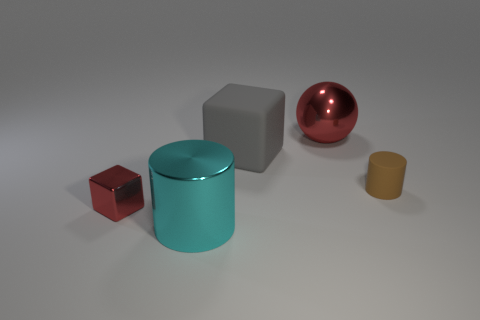What is the size of the red metallic sphere?
Your response must be concise. Large. Is the size of the cylinder in front of the rubber cylinder the same as the metallic thing that is behind the tiny metallic thing?
Give a very brief answer. Yes. There is a big object in front of the small brown cylinder that is in front of the big gray rubber object; what color is it?
Your answer should be compact. Cyan. There is a red thing that is the same size as the brown rubber object; what material is it?
Provide a short and direct response. Metal. What number of matte things are tiny brown things or big gray objects?
Offer a very short reply. 2. The object that is both left of the shiny ball and behind the metallic cube is what color?
Offer a terse response. Gray. How many tiny brown things are in front of the gray matte thing?
Keep it short and to the point. 1. What is the material of the brown thing?
Make the answer very short. Rubber. There is a thing behind the rubber object that is behind the cylinder behind the tiny metal cube; what color is it?
Provide a succinct answer. Red. What number of cylinders have the same size as the red block?
Make the answer very short. 1. 